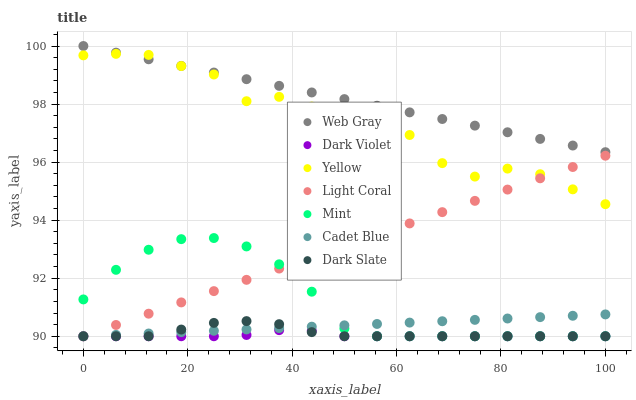Does Dark Violet have the minimum area under the curve?
Answer yes or no. Yes. Does Web Gray have the maximum area under the curve?
Answer yes or no. Yes. Does Yellow have the minimum area under the curve?
Answer yes or no. No. Does Yellow have the maximum area under the curve?
Answer yes or no. No. Is Cadet Blue the smoothest?
Answer yes or no. Yes. Is Yellow the roughest?
Answer yes or no. Yes. Is Light Coral the smoothest?
Answer yes or no. No. Is Light Coral the roughest?
Answer yes or no. No. Does Cadet Blue have the lowest value?
Answer yes or no. Yes. Does Yellow have the lowest value?
Answer yes or no. No. Does Web Gray have the highest value?
Answer yes or no. Yes. Does Yellow have the highest value?
Answer yes or no. No. Is Dark Violet less than Web Gray?
Answer yes or no. Yes. Is Web Gray greater than Dark Violet?
Answer yes or no. Yes. Does Light Coral intersect Yellow?
Answer yes or no. Yes. Is Light Coral less than Yellow?
Answer yes or no. No. Is Light Coral greater than Yellow?
Answer yes or no. No. Does Dark Violet intersect Web Gray?
Answer yes or no. No. 